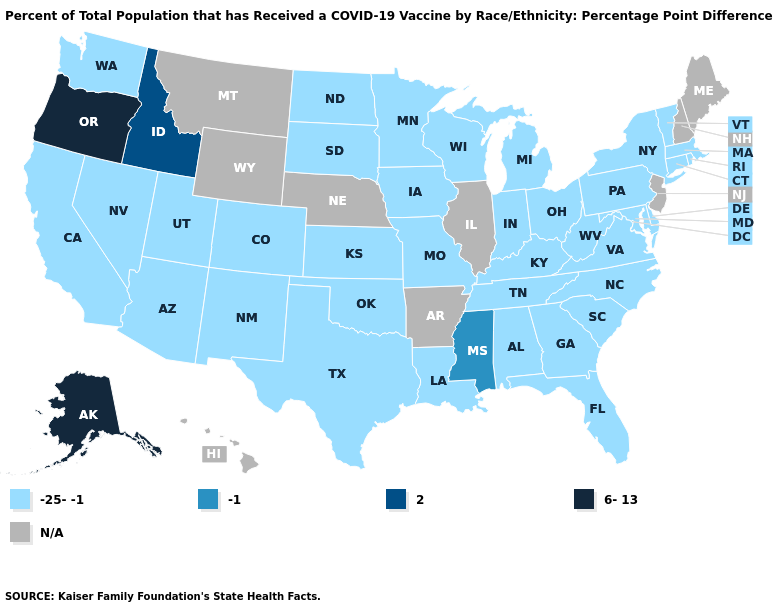Does Alaska have the lowest value in the West?
Write a very short answer. No. How many symbols are there in the legend?
Short answer required. 5. What is the value of Nebraska?
Be succinct. N/A. What is the value of Mississippi?
Quick response, please. -1. Among the states that border Louisiana , does Texas have the highest value?
Short answer required. No. What is the highest value in the USA?
Quick response, please. 6-13. Which states have the highest value in the USA?
Write a very short answer. Alaska, Oregon. What is the value of Kansas?
Write a very short answer. -25--1. What is the value of Hawaii?
Short answer required. N/A. What is the value of Vermont?
Be succinct. -25--1. Which states hav the highest value in the MidWest?
Quick response, please. Indiana, Iowa, Kansas, Michigan, Minnesota, Missouri, North Dakota, Ohio, South Dakota, Wisconsin. How many symbols are there in the legend?
Short answer required. 5. Name the states that have a value in the range -1?
Quick response, please. Mississippi. Which states have the lowest value in the USA?
Write a very short answer. Alabama, Arizona, California, Colorado, Connecticut, Delaware, Florida, Georgia, Indiana, Iowa, Kansas, Kentucky, Louisiana, Maryland, Massachusetts, Michigan, Minnesota, Missouri, Nevada, New Mexico, New York, North Carolina, North Dakota, Ohio, Oklahoma, Pennsylvania, Rhode Island, South Carolina, South Dakota, Tennessee, Texas, Utah, Vermont, Virginia, Washington, West Virginia, Wisconsin. What is the lowest value in the USA?
Be succinct. -25--1. 